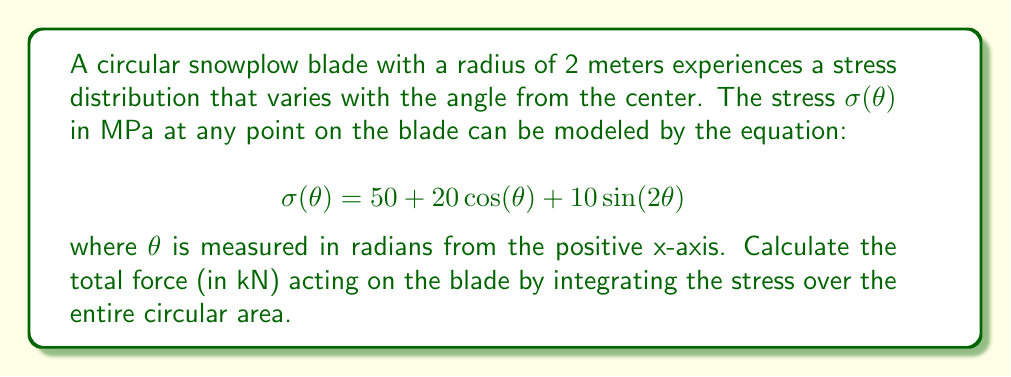Can you solve this math problem? To solve this problem, we need to integrate the stress function over the area of the circular blade using polar coordinates. Here's a step-by-step approach:

1) The force on an infinitesimal area element in polar coordinates is given by:

   $$dF = \sigma(\theta) \cdot r \, dr \, d\theta$$

2) To find the total force, we need to integrate this over the entire area:

   $$F = \int_0^{2\pi} \int_0^2 \sigma(\theta) \cdot r \, dr \, d\theta$$

3) Substituting the given stress function:

   $$F = \int_0^{2\pi} \int_0^2 (50 + 20\cos(\theta) + 10\sin(2\theta)) \cdot r \, dr \, d\theta$$

4) We can separate this into three integrals:

   $$F = \int_0^{2\pi} \int_0^2 50r \, dr \, d\theta + \int_0^{2\pi} \int_0^2 20r\cos(\theta) \, dr \, d\theta + \int_0^{2\pi} \int_0^2 10r\sin(2\theta) \, dr \, d\theta$$

5) Let's evaluate each integral separately:

   a) $\int_0^{2\pi} \int_0^2 50r \, dr \, d\theta = 50 \cdot 2\pi \cdot \int_0^2 r \, dr = 50 \cdot 2\pi \cdot \frac{r^2}{2}|_0^2 = 200\pi$

   b) $\int_0^{2\pi} \int_0^2 20r\cos(\theta) \, dr \, d\theta = 20 \cdot \int_0^2 r \, dr \cdot \int_0^{2\pi} \cos(\theta) \, d\theta = 20 \cdot 2 \cdot 0 = 0$

   c) $\int_0^{2\pi} \int_0^2 10r\sin(2\theta) \, dr \, d\theta = 10 \cdot \int_0^2 r \, dr \cdot \int_0^{2\pi} \sin(2\theta) \, d\theta = 10 \cdot 2 \cdot 0 = 0$

6) The total force is the sum of these results:

   $$F = 200\pi + 0 + 0 = 200\pi \text{ N}$$

7) Converting to kN:

   $$F = 200\pi \cdot 10^{-3} = 0.2\pi \text{ kN}$$
Answer: $0.2\pi \approx 0.628 \text{ kN}$ 